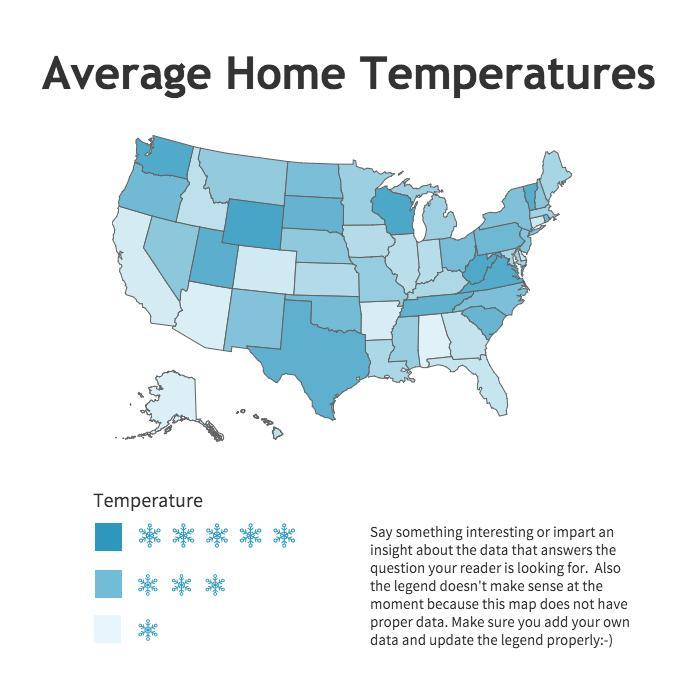how many types of temperature ranges are shown
Answer the question with a short phrase. 3 